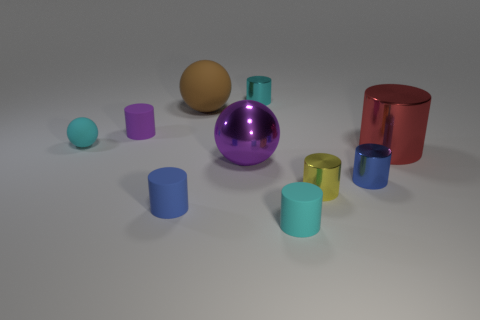Can you describe the texture of the objects in the image? Certainly! The objects in the image display various textures. The cylinders and spheres appear to have smooth surfaces, suggesting a metallic or plastic material. The reflections and sheen on some indicate a polished finish. The large purple sphere, in particular, has a reflective, glossy texture that stands out among the others. 